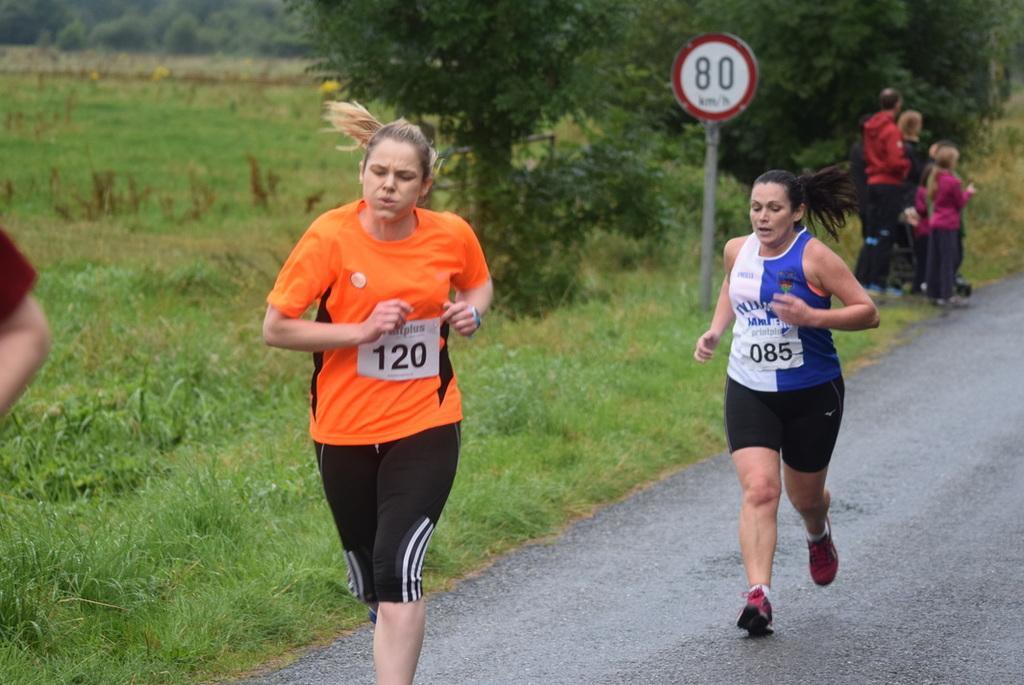Please provide a concise description of this image. In this image we can see two women running on a road and there are a group of people standing beside the road and on the left side of the image there are trees, grass and a board attached to the pole. 